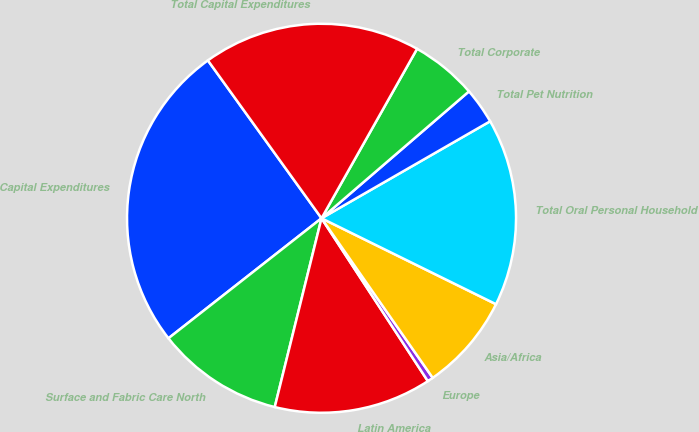Convert chart. <chart><loc_0><loc_0><loc_500><loc_500><pie_chart><fcel>Capital Expenditures<fcel>Surface and Fabric Care North<fcel>Latin America<fcel>Europe<fcel>Asia/Africa<fcel>Total Oral Personal Household<fcel>Total Pet Nutrition<fcel>Total Corporate<fcel>Total Capital Expenditures<nl><fcel>25.65%<fcel>10.55%<fcel>13.07%<fcel>0.48%<fcel>8.03%<fcel>15.59%<fcel>3.0%<fcel>5.52%<fcel>18.1%<nl></chart> 